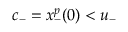Convert formula to latex. <formula><loc_0><loc_0><loc_500><loc_500>c _ { - } = x _ { - } ^ { p } ( 0 ) < u _ { - }</formula> 